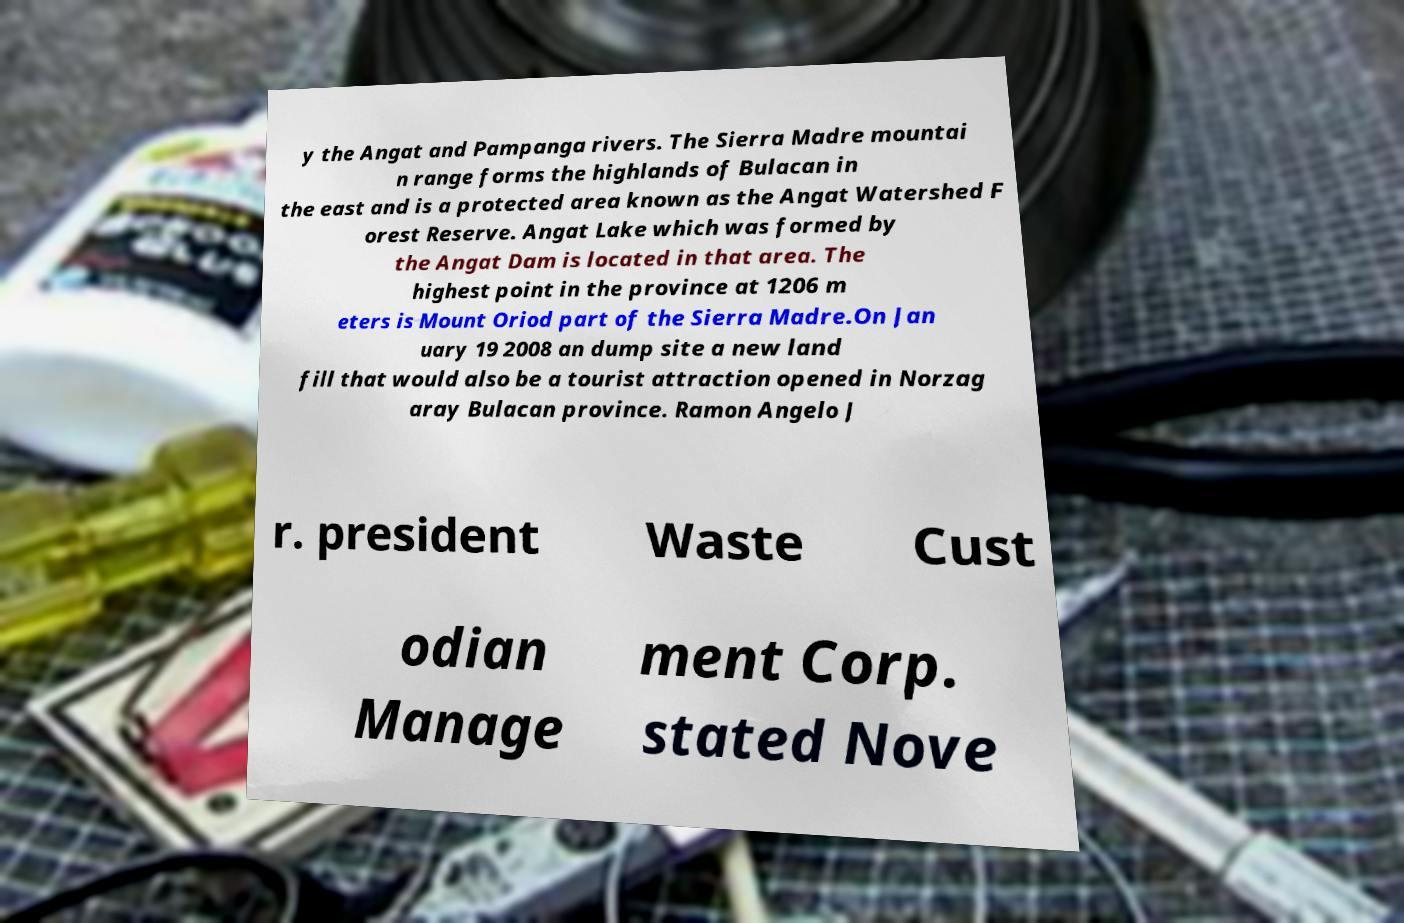What messages or text are displayed in this image? I need them in a readable, typed format. y the Angat and Pampanga rivers. The Sierra Madre mountai n range forms the highlands of Bulacan in the east and is a protected area known as the Angat Watershed F orest Reserve. Angat Lake which was formed by the Angat Dam is located in that area. The highest point in the province at 1206 m eters is Mount Oriod part of the Sierra Madre.On Jan uary 19 2008 an dump site a new land fill that would also be a tourist attraction opened in Norzag aray Bulacan province. Ramon Angelo J r. president Waste Cust odian Manage ment Corp. stated Nove 